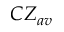<formula> <loc_0><loc_0><loc_500><loc_500>C Z _ { a v }</formula> 